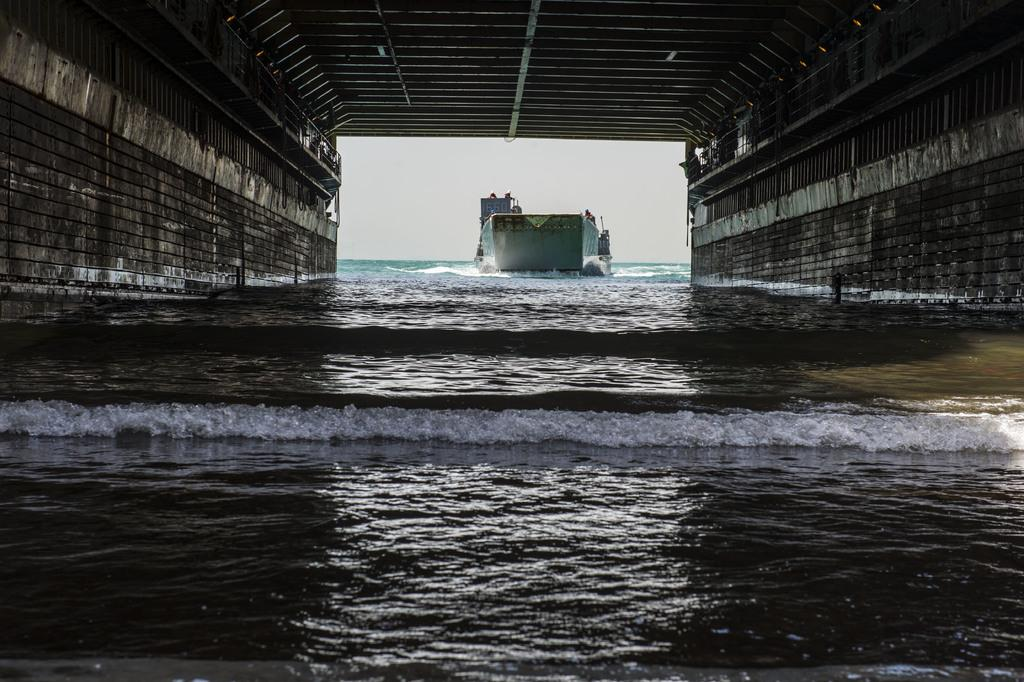What is the main feature of the image? The main feature of the image is water. What structure can be seen in the image? There is a bridge in the image. What object is floating in the water? There is a boat in the middle of the image. What type of jewel is hanging from the bridge in the image? There is no jewel hanging from the bridge in the image; it only features a bridge, water, and a boat. 